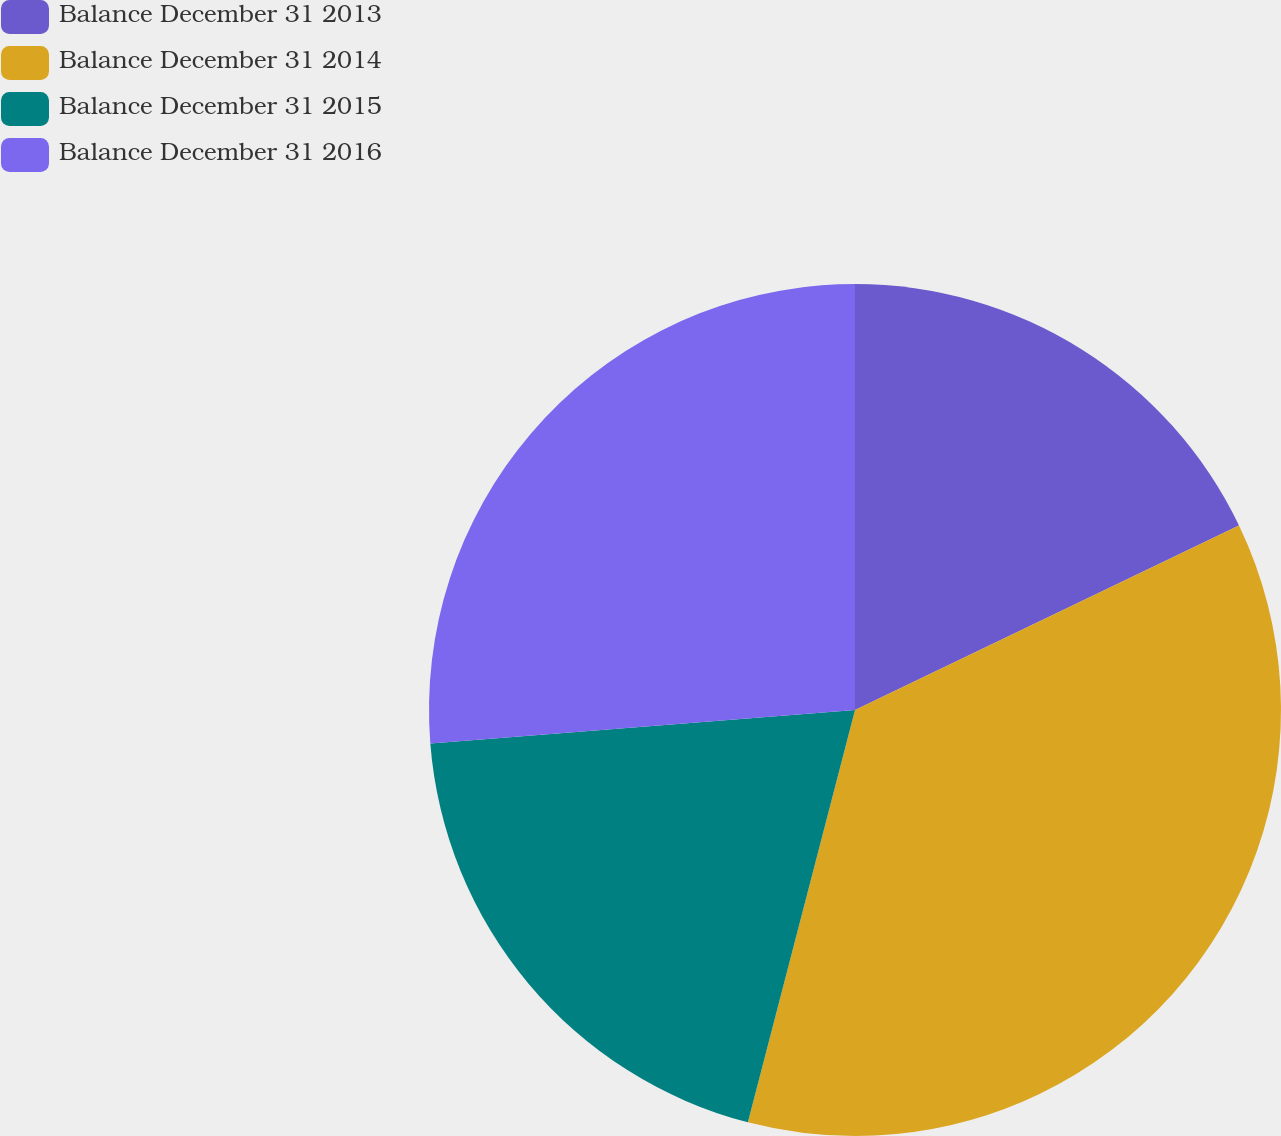<chart> <loc_0><loc_0><loc_500><loc_500><pie_chart><fcel>Balance December 31 2013<fcel>Balance December 31 2014<fcel>Balance December 31 2015<fcel>Balance December 31 2016<nl><fcel>17.87%<fcel>36.17%<fcel>19.7%<fcel>26.25%<nl></chart> 